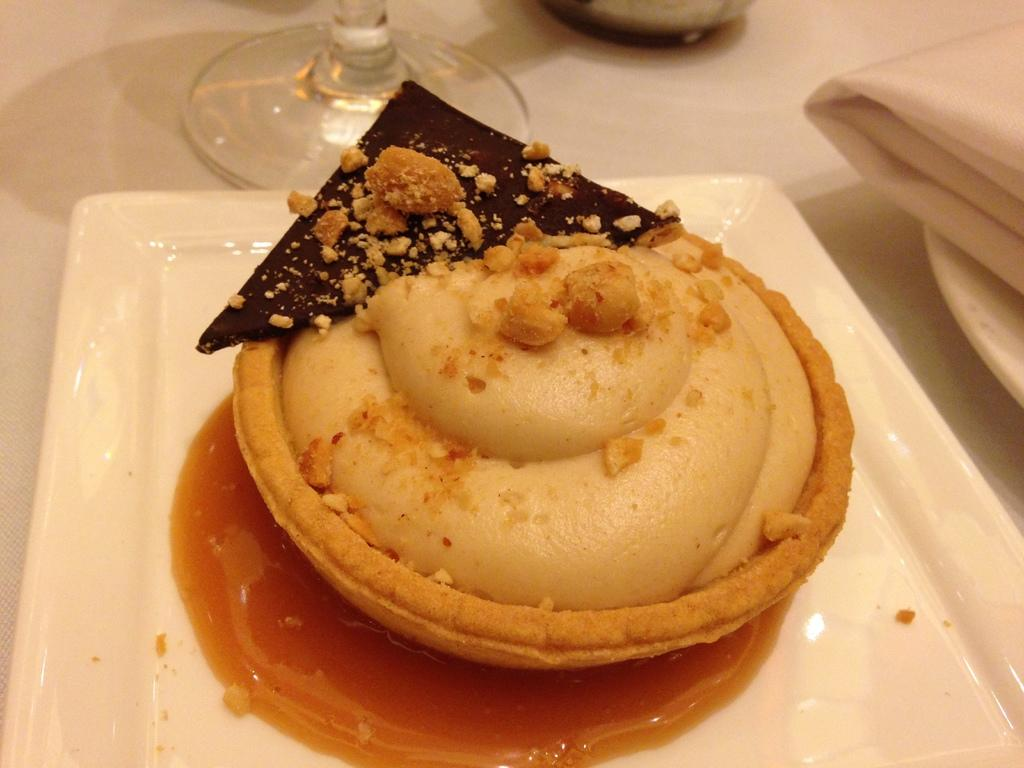What is the main food item visible on the plate in the image? The specific food item is not mentioned, but there is a food item on a white plate in the image. What is located on the right side of the image? There is a white napkin on the right side of the image. What type of glass can be seen at the back of the image? There is a wine glass at the back of the image. What type of toy is being used as a punishment in the image? There is no toy or punishment present in the image. 